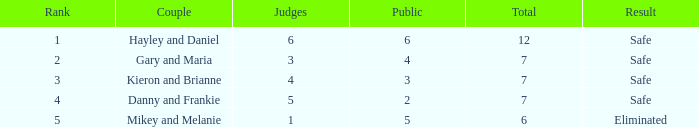What was the total number when the vote percentage was 44.8%? 1.0. 